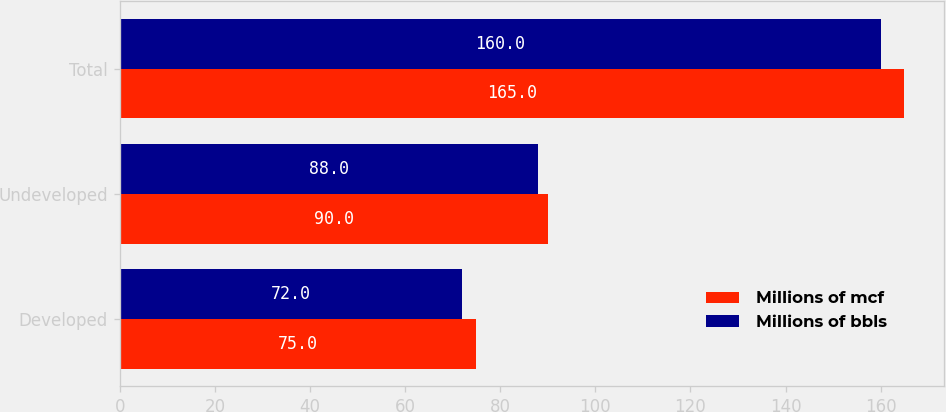Convert chart. <chart><loc_0><loc_0><loc_500><loc_500><stacked_bar_chart><ecel><fcel>Developed<fcel>Undeveloped<fcel>Total<nl><fcel>Millions of mcf<fcel>75<fcel>90<fcel>165<nl><fcel>Millions of bbls<fcel>72<fcel>88<fcel>160<nl></chart> 